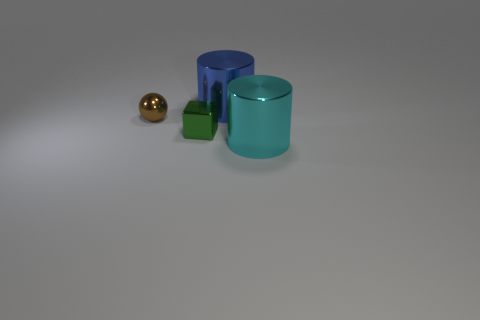Subtract all cubes. How many objects are left? 3 Add 2 brown metal objects. How many brown metal objects exist? 3 Add 4 large blue objects. How many objects exist? 8 Subtract 0 purple blocks. How many objects are left? 4 Subtract 1 cylinders. How many cylinders are left? 1 Subtract all cyan cylinders. Subtract all cyan cubes. How many cylinders are left? 1 Subtract all blue cubes. How many purple cylinders are left? 0 Subtract all large blue things. Subtract all small green shiny objects. How many objects are left? 2 Add 1 brown metal objects. How many brown metal objects are left? 2 